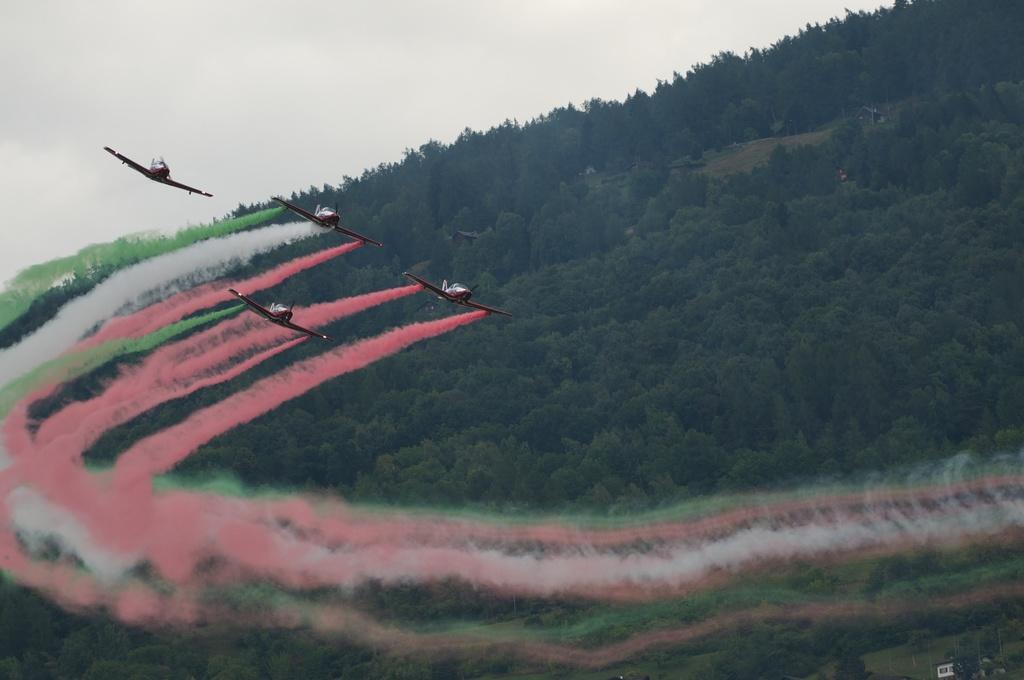In one or two sentences, can you explain what this image depicts? In this picture we can see few planes in the air, in the background we can find few trees. 